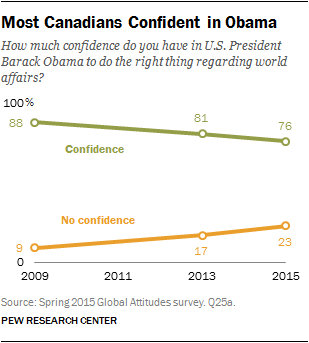List a handful of essential elements in this visual. The color of the graph in 2009 was orange, and its value was 9. The difference between the green and orange graphs is minimum in the year 2015. 